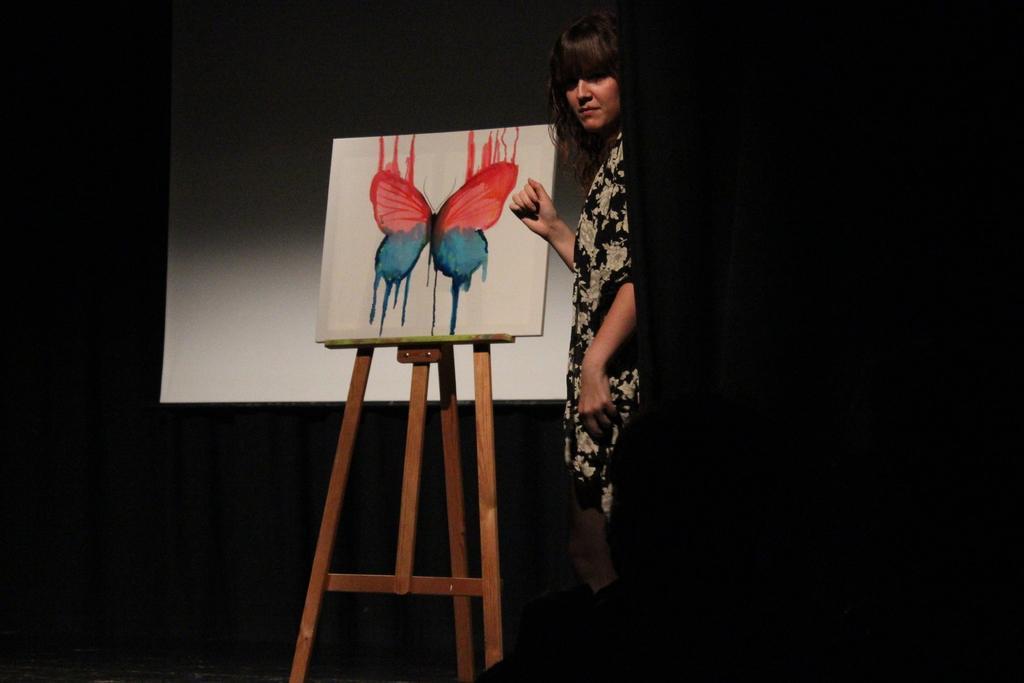In one or two sentences, can you explain what this image depicts? In this image we can see a person standing. We can see a board included with a stand and we can also see a butterfly painting on the board. In the background we can see the projector screen. 